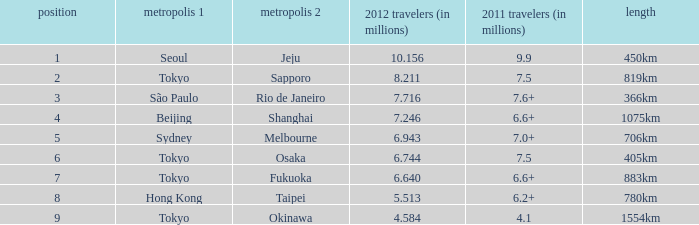What the is the first city listed on the route that had 6.6+ passengers in 2011 and a distance of 1075km? Beijing. Would you be able to parse every entry in this table? {'header': ['position', 'metropolis 1', 'metropolis 2', '2012 travelers (in millions)', '2011 travelers (in millions)', 'length'], 'rows': [['1', 'Seoul', 'Jeju', '10.156', '9.9', '450km'], ['2', 'Tokyo', 'Sapporo', '8.211', '7.5', '819km'], ['3', 'São Paulo', 'Rio de Janeiro', '7.716', '7.6+', '366km'], ['4', 'Beijing', 'Shanghai', '7.246', '6.6+', '1075km'], ['5', 'Sydney', 'Melbourne', '6.943', '7.0+', '706km'], ['6', 'Tokyo', 'Osaka', '6.744', '7.5', '405km'], ['7', 'Tokyo', 'Fukuoka', '6.640', '6.6+', '883km'], ['8', 'Hong Kong', 'Taipei', '5.513', '6.2+', '780km'], ['9', 'Tokyo', 'Okinawa', '4.584', '4.1', '1554km']]} 